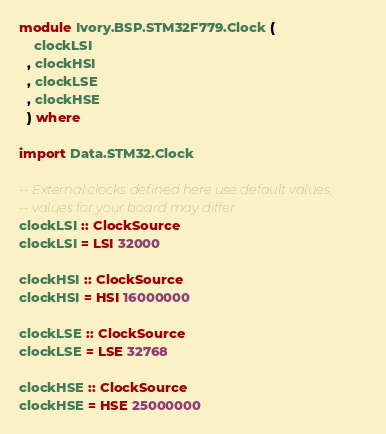<code> <loc_0><loc_0><loc_500><loc_500><_Haskell_>module Ivory.BSP.STM32F779.Clock (
    clockLSI
  , clockHSI
  , clockLSE
  , clockHSE
  ) where

import Data.STM32.Clock

-- External clocks defined here use default values,
-- values for your board may differ
clockLSI :: ClockSource
clockLSI = LSI 32000

clockHSI :: ClockSource
clockHSI = HSI 16000000

clockLSE :: ClockSource
clockLSE = LSE 32768

clockHSE :: ClockSource
clockHSE = HSE 25000000

</code> 